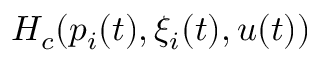Convert formula to latex. <formula><loc_0><loc_0><loc_500><loc_500>H _ { c } ( p _ { i } ( t ) , \xi _ { i } ( t ) , u ( t ) )</formula> 